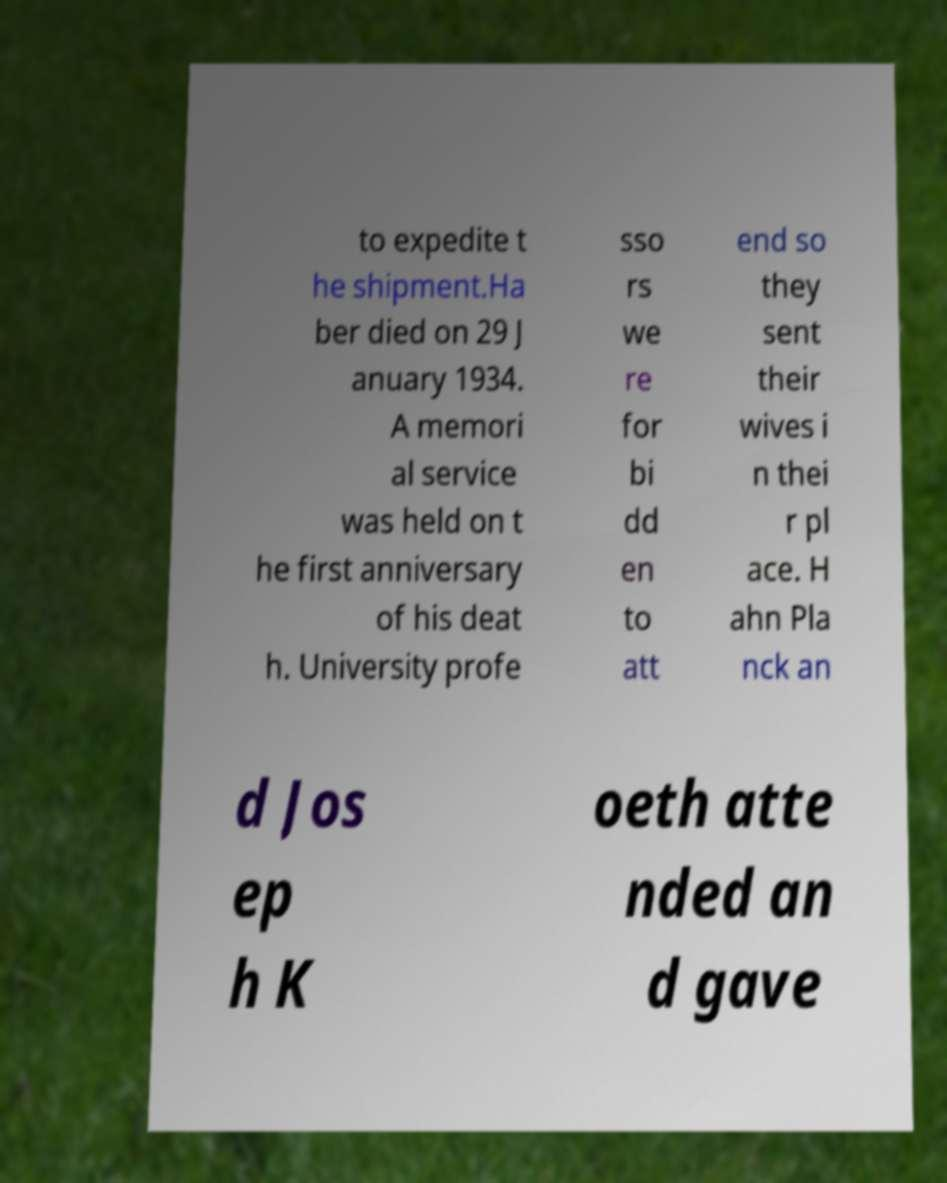Please read and relay the text visible in this image. What does it say? to expedite t he shipment.Ha ber died on 29 J anuary 1934. A memori al service was held on t he first anniversary of his deat h. University profe sso rs we re for bi dd en to att end so they sent their wives i n thei r pl ace. H ahn Pla nck an d Jos ep h K oeth atte nded an d gave 